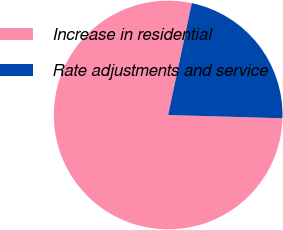Convert chart. <chart><loc_0><loc_0><loc_500><loc_500><pie_chart><fcel>Increase in residential<fcel>Rate adjustments and service<nl><fcel>77.86%<fcel>22.14%<nl></chart> 